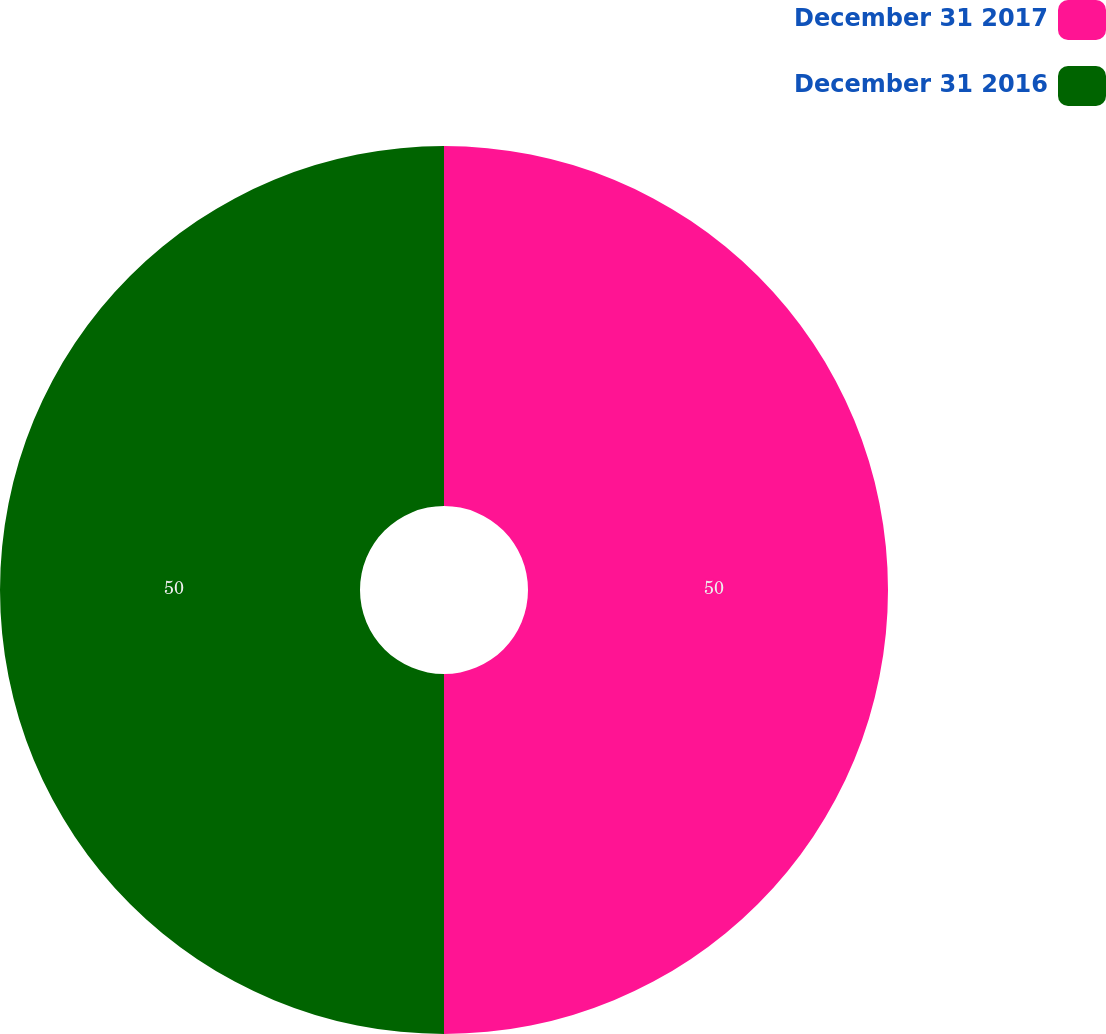Convert chart to OTSL. <chart><loc_0><loc_0><loc_500><loc_500><pie_chart><fcel>December 31 2017<fcel>December 31 2016<nl><fcel>50.0%<fcel>50.0%<nl></chart> 